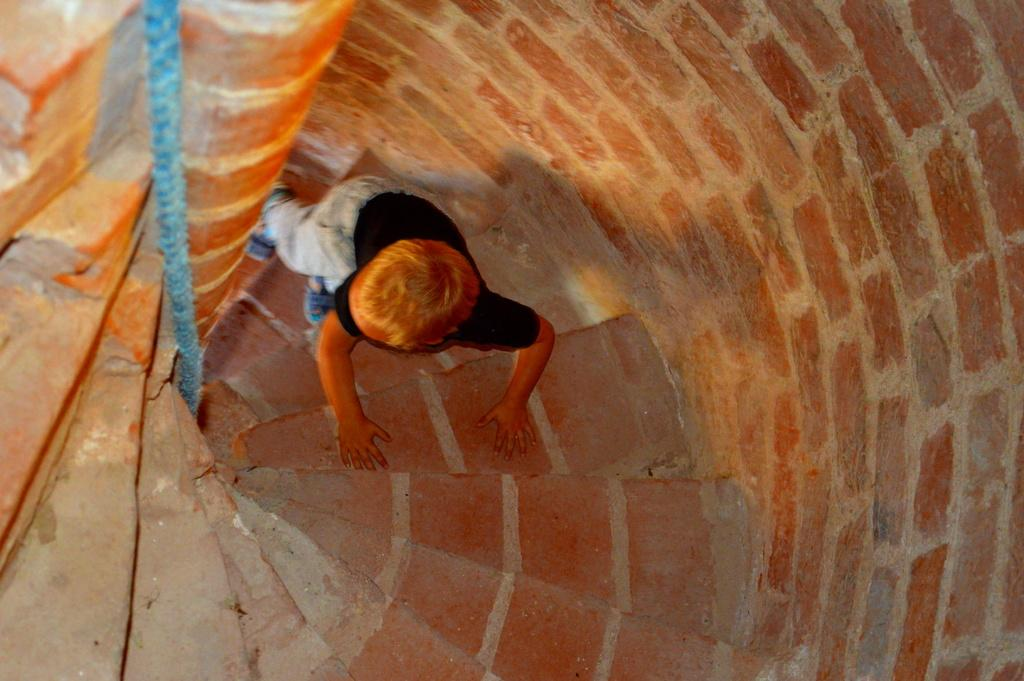Who is the main subject in the image? There is a boy in the image. What is the boy doing in the image? The boy is climbing steps. What can be seen beside the boy in the image? There is a brick wall beside the boy. How many rings is the boy wearing on his nose in the image? There is no mention of rings or the boy's nose in the image, so it cannot be determined. 